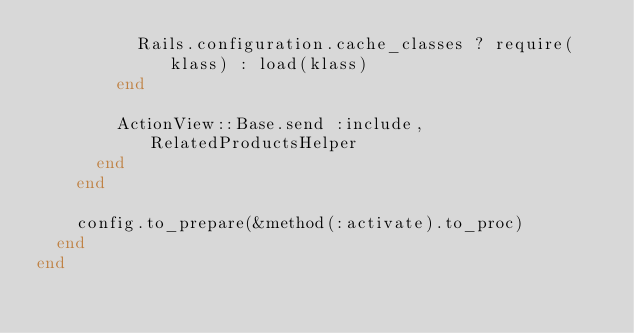<code> <loc_0><loc_0><loc_500><loc_500><_Ruby_>          Rails.configuration.cache_classes ? require(klass) : load(klass)
        end

        ActionView::Base.send :include, RelatedProductsHelper
      end
    end

    config.to_prepare(&method(:activate).to_proc)
  end
end</code> 